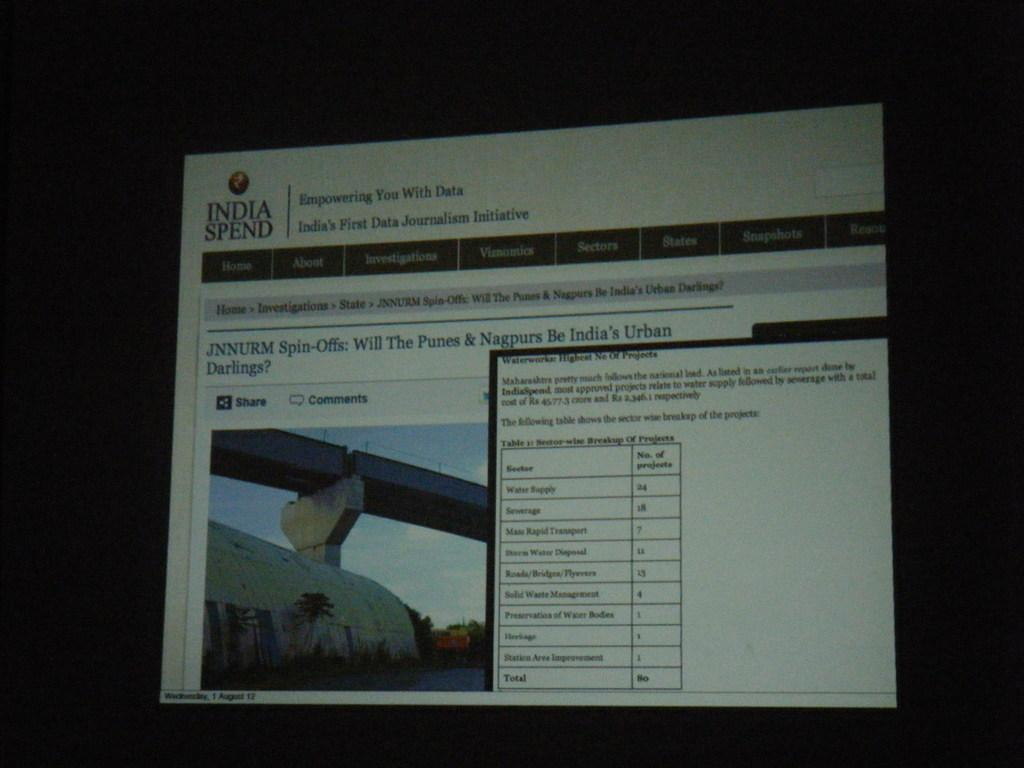<image>
Summarize the visual content of the image. An Internet browser is open to an India Spend website. 